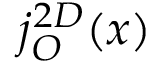<formula> <loc_0><loc_0><loc_500><loc_500>j _ { O } ^ { 2 D } ( x )</formula> 